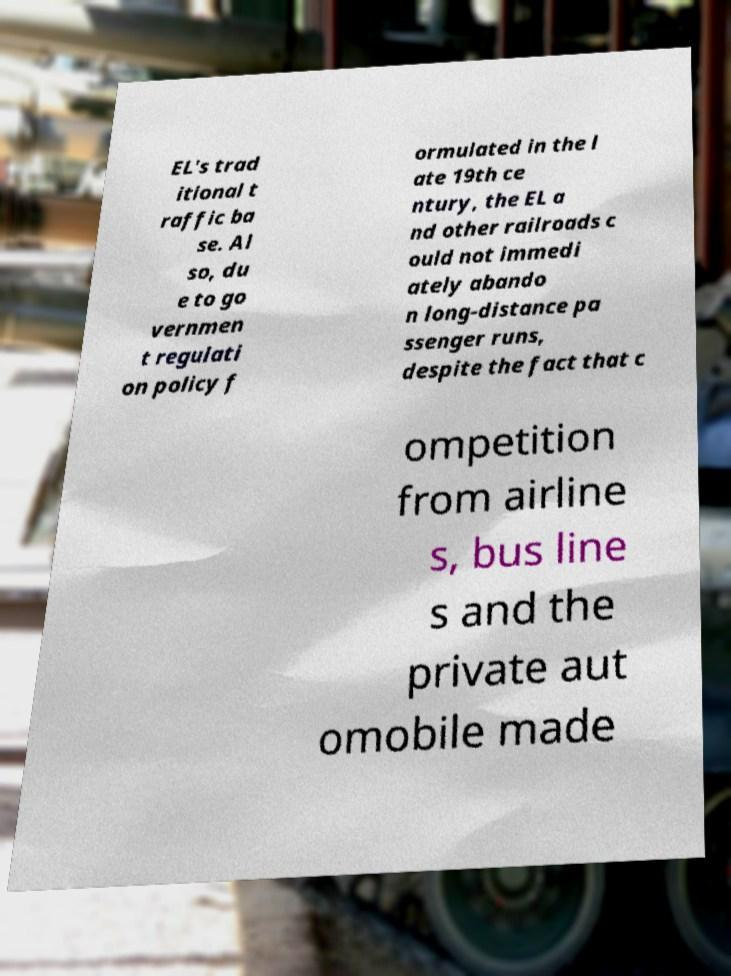For documentation purposes, I need the text within this image transcribed. Could you provide that? EL's trad itional t raffic ba se. Al so, du e to go vernmen t regulati on policy f ormulated in the l ate 19th ce ntury, the EL a nd other railroads c ould not immedi ately abando n long-distance pa ssenger runs, despite the fact that c ompetition from airline s, bus line s and the private aut omobile made 